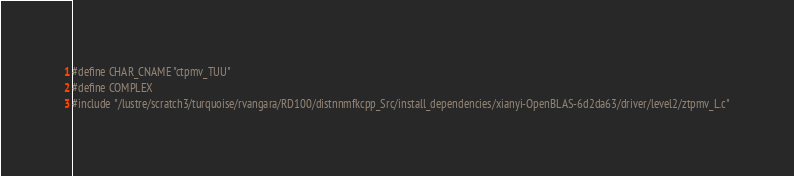<code> <loc_0><loc_0><loc_500><loc_500><_C_>#define CHAR_CNAME "ctpmv_TUU"
#define COMPLEX
#include "/lustre/scratch3/turquoise/rvangara/RD100/distnnmfkcpp_Src/install_dependencies/xianyi-OpenBLAS-6d2da63/driver/level2/ztpmv_L.c"</code> 